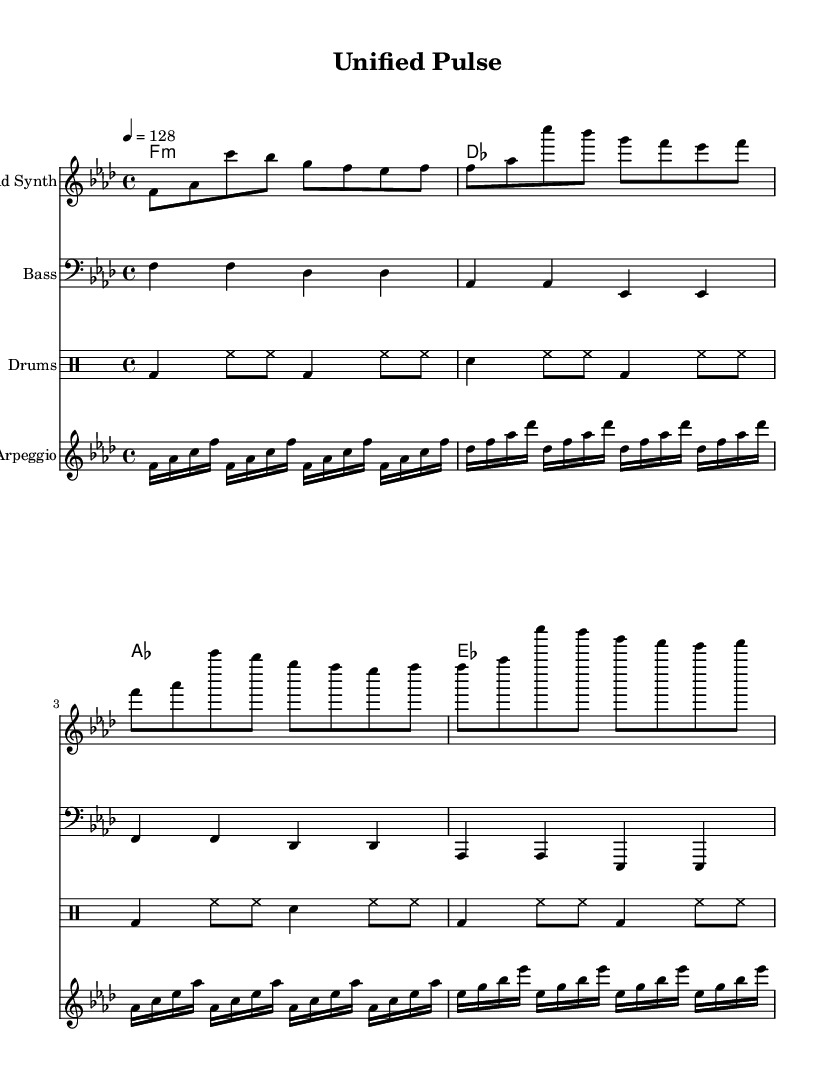What is the key signature of this music? The key signature indicated in the global section shows an F minor key, which has four flats (B, E, A, and D).
Answer: F minor What is the time signature of this music? The time signature shown in the global section is 4/4, indicating four beats in a measure with a quarter note receiving one beat.
Answer: 4/4 What is the tempo marking? The tempo marking specified in the global section is quarter note equals 128, which indicates a moderately fast tempo.
Answer: 128 How many measures are in the melody section? The melody section has a total of four measures, each containing eight eighth notes (as seen in the notation), leading to four complete repetitions of the eight-note pattern.
Answer: 4 What instruments are used in this piece? The score includes four distinct instruments: a lead synth for the melody, a bass instrument, a drum staff, and an arpeggio staff, as indicated in the score section of the code.
Answer: Lead Synth, Bass, Drums, Arpeggio What rhythmic pattern is primarily used in the drum section? The drum section features a consistent pattern of bass drum and hi-hat being played quarter, eighth, and back to quarter notes, creating an energetic driving rhythm typical in house music.
Answer: Bass and Hi-Hat pattern Which musical element emphasizes the theme of cooperation in this piece? The repeating and structured arpeggio patterns throughout the piece create a sense of unity and collaboration between the instrumental layers, reflecting the theme of cooperation and togetherness in music form.
Answer: Arpeggio patterns 